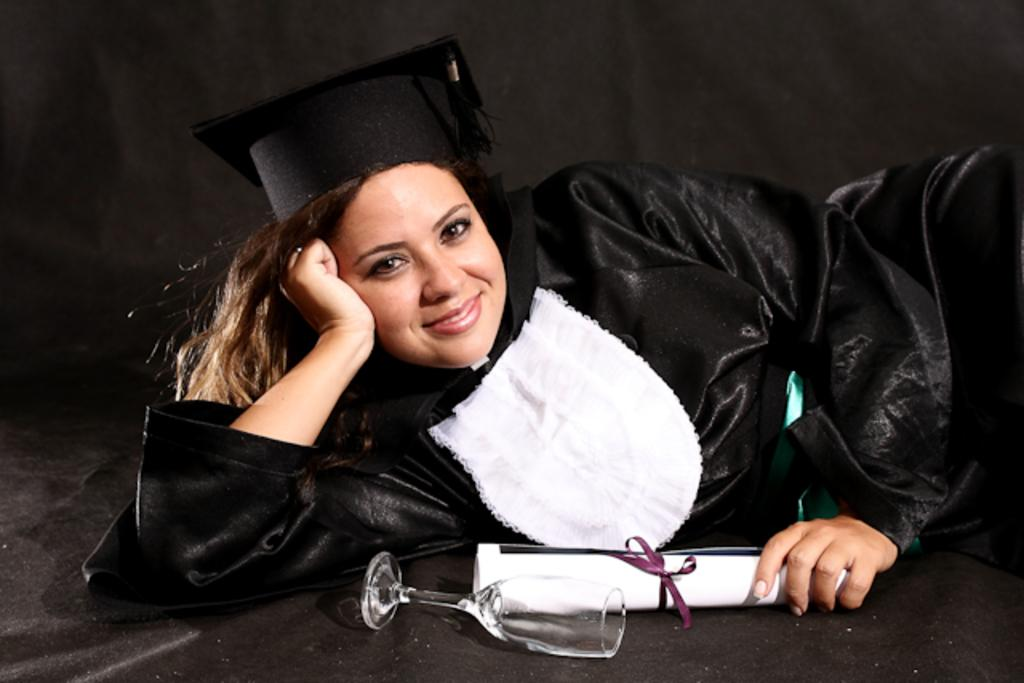What is the person in the image wearing? There is a person wearing a costume in the image. What is the position of the other person in the image? There is a person lying on the ground in the image. What can be seen besides the people in the image? There is an object in the image. What might be used for drinking in the image? There is a drinking glass in the image. How many goats are visible in the image? There are no goats present in the image. What is the profit margin of the costume in the image? There is no information about the profit margin of the costume in the image. 